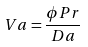Convert formula to latex. <formula><loc_0><loc_0><loc_500><loc_500>V a = \frac { \phi P r } { D a }</formula> 